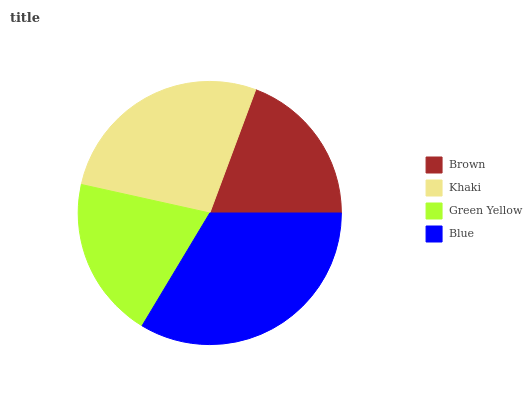Is Brown the minimum?
Answer yes or no. Yes. Is Blue the maximum?
Answer yes or no. Yes. Is Khaki the minimum?
Answer yes or no. No. Is Khaki the maximum?
Answer yes or no. No. Is Khaki greater than Brown?
Answer yes or no. Yes. Is Brown less than Khaki?
Answer yes or no. Yes. Is Brown greater than Khaki?
Answer yes or no. No. Is Khaki less than Brown?
Answer yes or no. No. Is Khaki the high median?
Answer yes or no. Yes. Is Green Yellow the low median?
Answer yes or no. Yes. Is Green Yellow the high median?
Answer yes or no. No. Is Blue the low median?
Answer yes or no. No. 